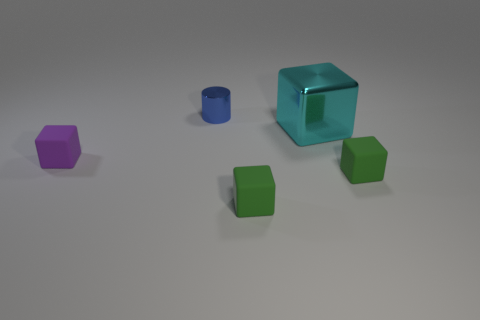Add 4 blue metallic cylinders. How many objects exist? 9 Subtract all tiny matte cubes. How many cubes are left? 1 Subtract 1 cylinders. How many cylinders are left? 0 Subtract all green cubes. How many cubes are left? 2 Subtract all cylinders. How many objects are left? 4 Subtract all brown cylinders. How many green cubes are left? 2 Subtract all tiny green rubber blocks. Subtract all small shiny cylinders. How many objects are left? 2 Add 1 cylinders. How many cylinders are left? 2 Add 1 metal cylinders. How many metal cylinders exist? 2 Subtract 0 red cylinders. How many objects are left? 5 